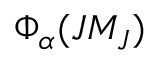<formula> <loc_0><loc_0><loc_500><loc_500>\Phi _ { \alpha } ( J M _ { J } )</formula> 